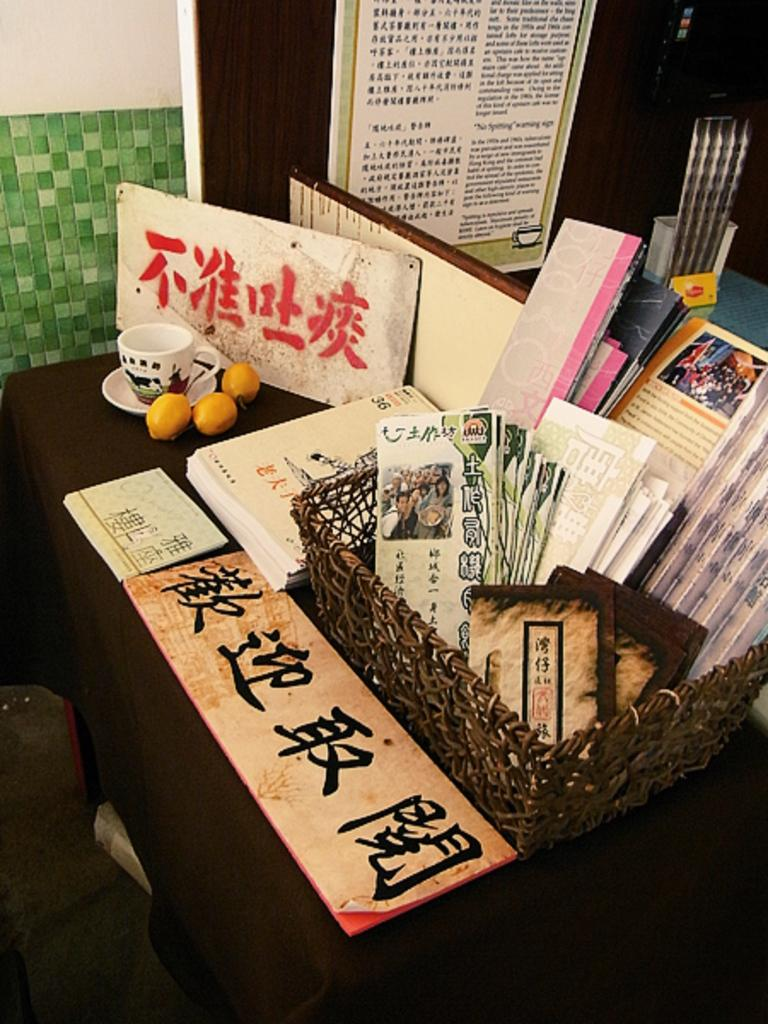What type of container is visible in the image? There is a wooden basket in the image. What is inside the wooden basket? There are books in the wooden basket. What type of dishware is present in the image? There is a cup and a saucer in the image. How many oranges can be seen in the image? There are three oranges in the image. What other objects can be seen in the image? There is a board, a poster, and a wall in the image. What type of holiday is being celebrated in the image? There is no indication of a holiday being celebrated in the image. How many people are riding in the carriage in the image? There is no carriage present in the image. 